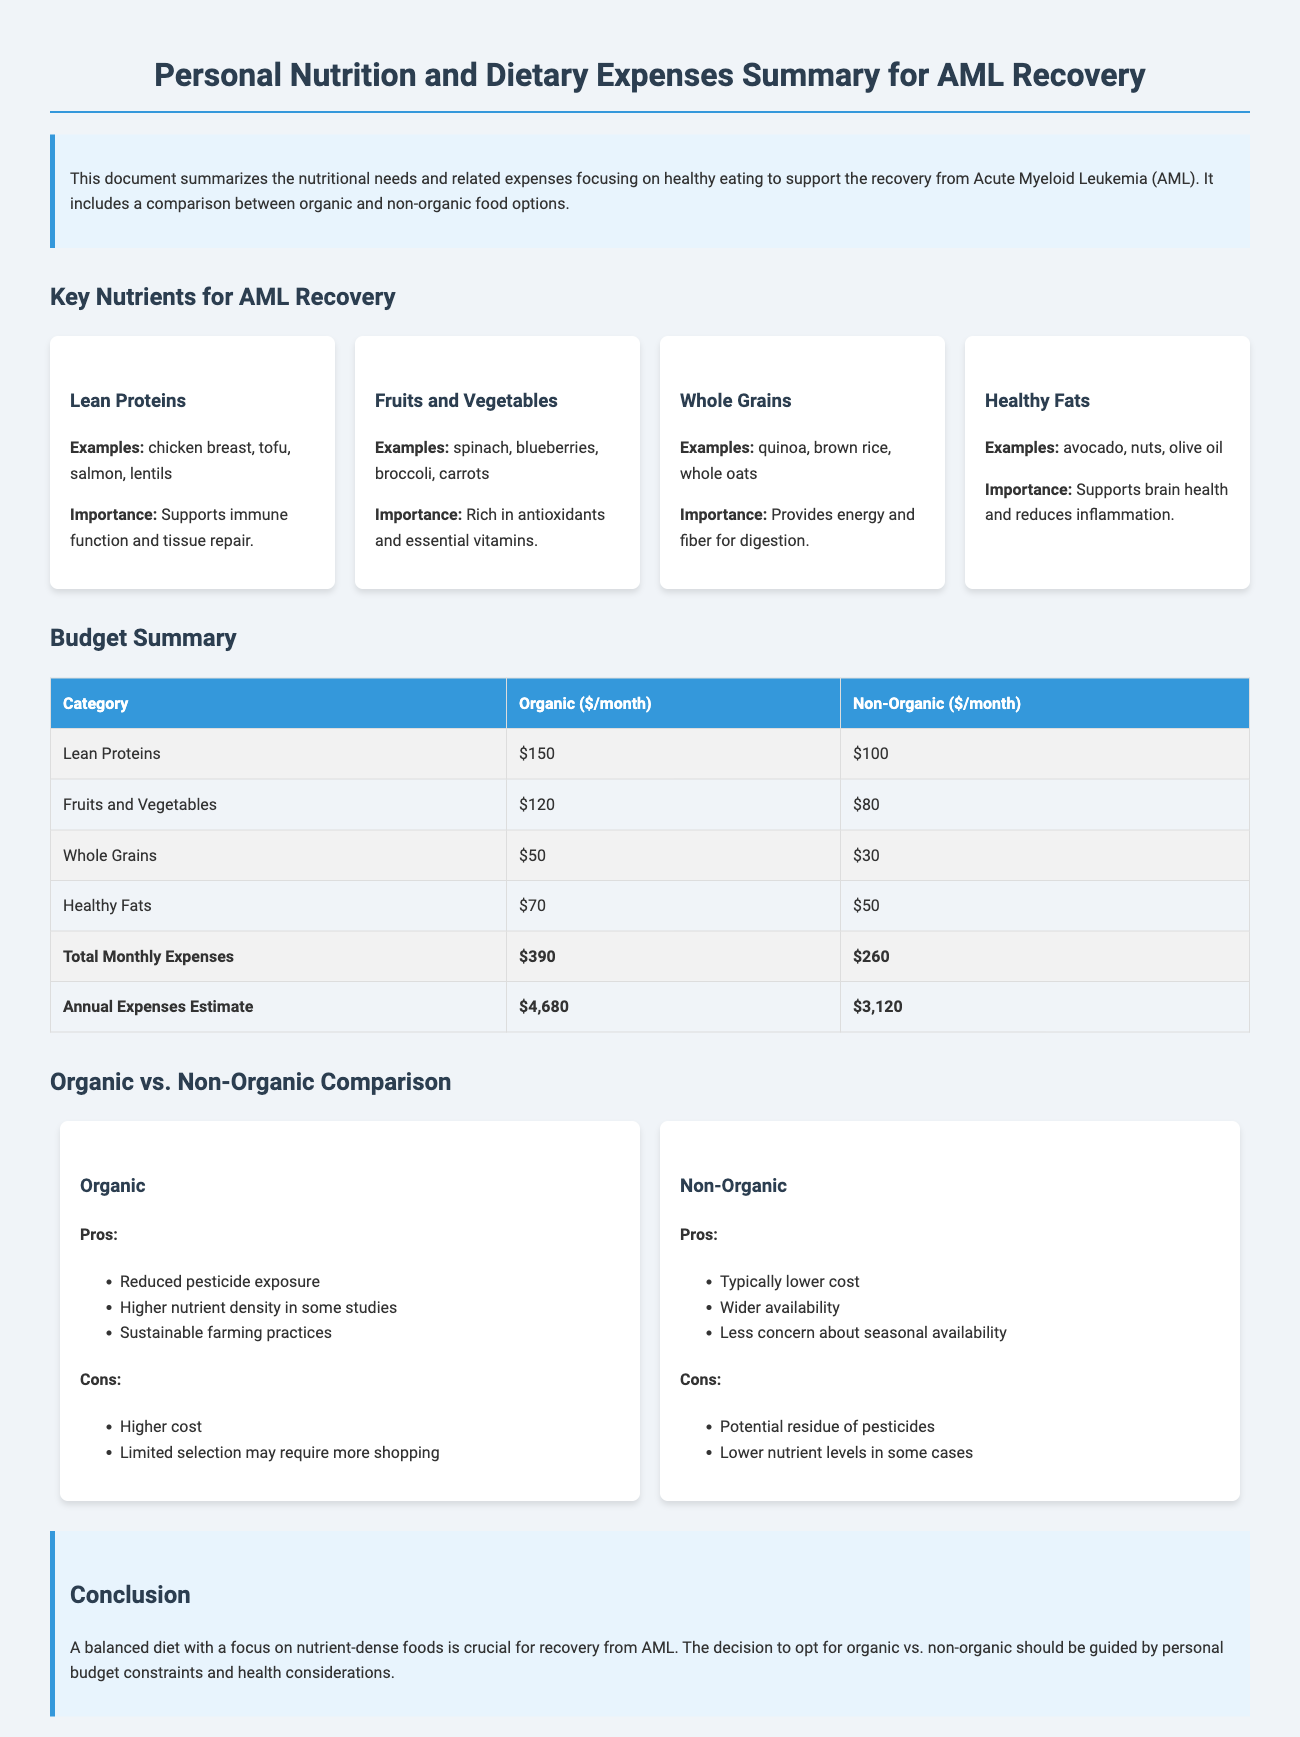what is the total monthly expense for organic options? The total monthly expense for organic options is listed in the budget summary table, which shows $390 for organic foods.
Answer: $390 what is the total monthly expense for non-organic options? The total monthly expense for non-organic options is indicated in the budget summary table, which shows $260 for non-organic foods.
Answer: $260 which nutrient supports immune function and tissue repair? The document mentions that lean proteins support immune function and tissue repair in the key nutrients section.
Answer: Lean Proteins what are the pros of choosing organic foods? The document lists pros of organic foods in the comparison section, including reduced pesticide exposure and higher nutrient density.
Answer: Reduced pesticide exposure, higher nutrient density what is the estimated annual expense for non-organic foods? The estimated annual expense for non-organic foods is shown in the budget summary table, which indicates $3,120.
Answer: $3,120 which nutrient provides energy and fiber for digestion? The document specifies that whole grains provide energy and fiber for digestion.
Answer: Whole Grains what is one con of non-organic foods? The document lists potential pesticide residue as a con of non-organic foods in the comparison section.
Answer: Potential residue of pesticides how much are healthy fats per month for organic options? The budget summary table specifies that healthy fats cost $70 per month for organic options.
Answer: $70 what is the importance of fruits and vegetables in the diet? The document explains that fruits and vegetables are rich in antioxidants and essential vitamins in the nutrient section.
Answer: Rich in antioxidants and essential vitamins 